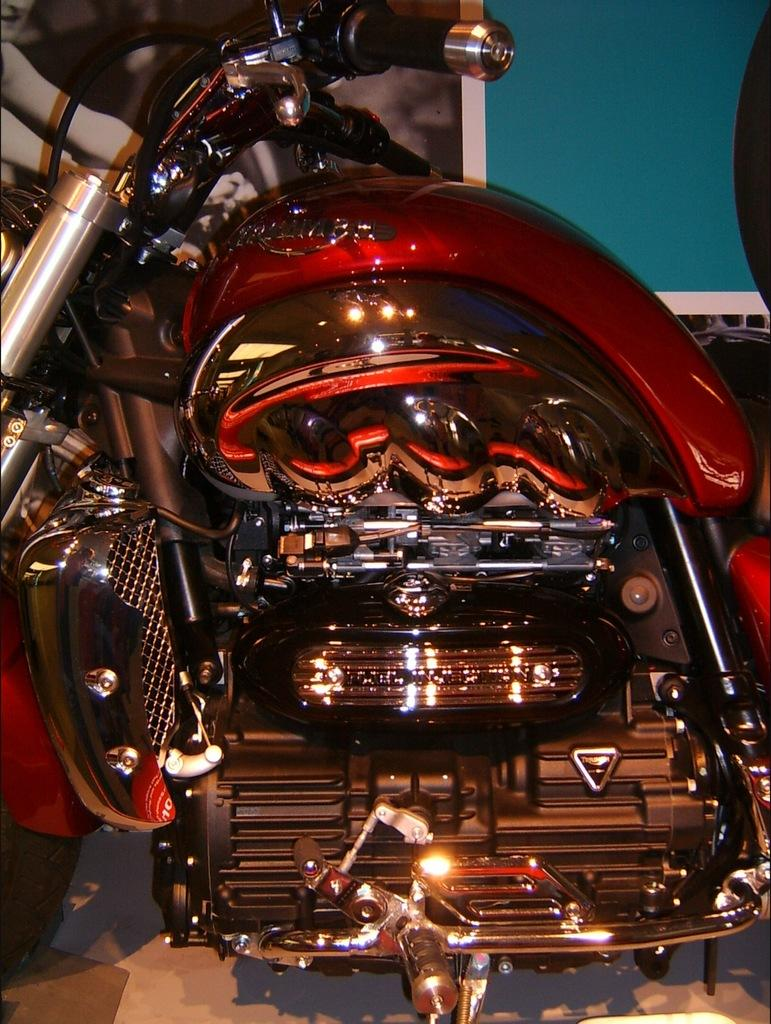What is the main object in the image? There is a bike in the image. Can you describe the person in relation to the bike? There is a person behind the bike. What else is visible in the image? There is a board in the top right corner of the image. What is the mass of the curve on the bike in the image? There is no curve mentioned in the image, and therefore no mass can be determined. 